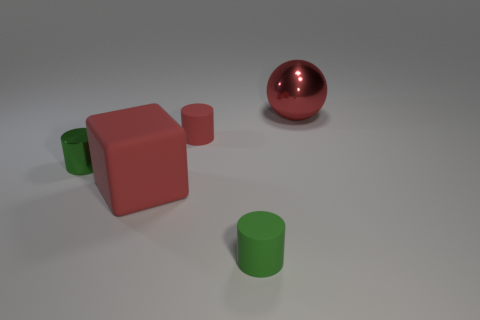Subtract all red blocks. How many green cylinders are left? 2 Add 3 tiny blue shiny spheres. How many objects exist? 8 Subtract all metallic cylinders. How many cylinders are left? 2 Subtract 1 cylinders. How many cylinders are left? 2 Subtract all cylinders. How many objects are left? 2 Subtract 0 gray cylinders. How many objects are left? 5 Subtract all brown cylinders. Subtract all yellow blocks. How many cylinders are left? 3 Subtract all tiny red rubber things. Subtract all green rubber objects. How many objects are left? 3 Add 5 small red rubber things. How many small red rubber things are left? 6 Add 4 large metal things. How many large metal things exist? 5 